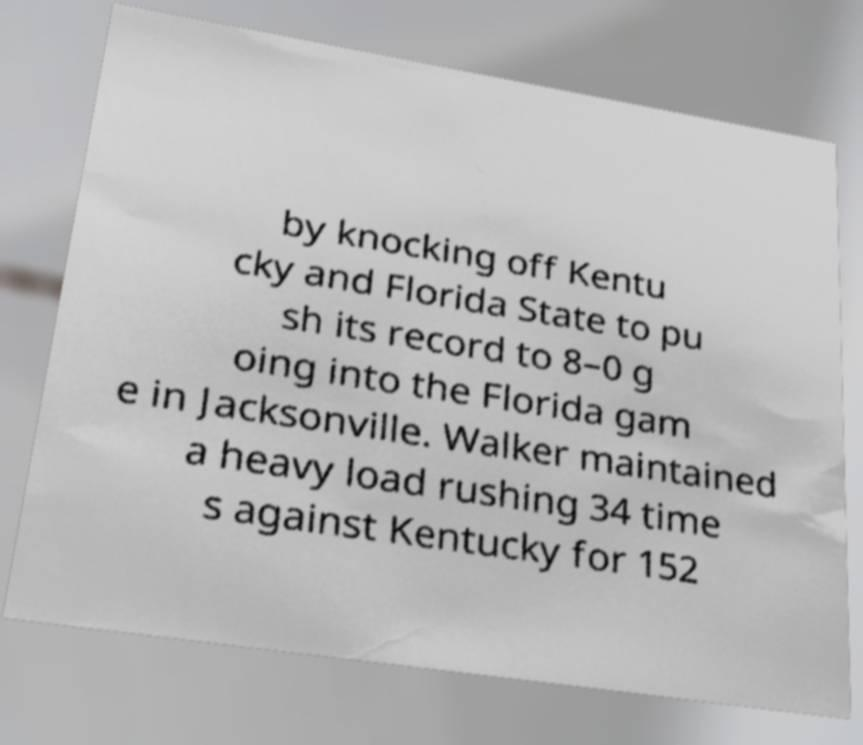Could you extract and type out the text from this image? by knocking off Kentu cky and Florida State to pu sh its record to 8–0 g oing into the Florida gam e in Jacksonville. Walker maintained a heavy load rushing 34 time s against Kentucky for 152 